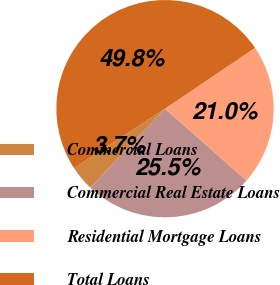<chart> <loc_0><loc_0><loc_500><loc_500><pie_chart><fcel>Commercial Loans<fcel>Commercial Real Estate Loans<fcel>Residential Mortgage Loans<fcel>Total Loans<nl><fcel>3.73%<fcel>25.55%<fcel>20.95%<fcel>49.77%<nl></chart> 